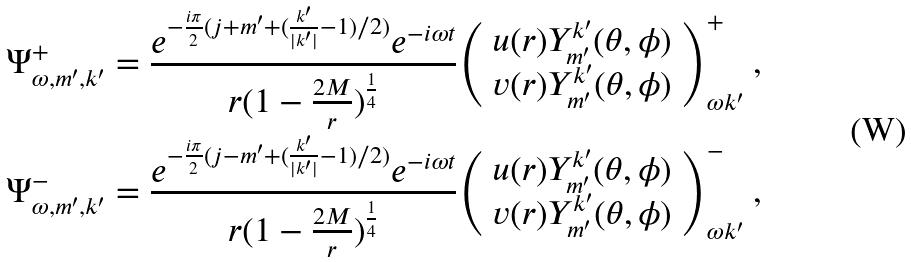Convert formula to latex. <formula><loc_0><loc_0><loc_500><loc_500>\Psi ^ { + } _ { \omega , m ^ { \prime } , k ^ { \prime } } & = \frac { e ^ { - \frac { i \pi } { 2 } ( j + m ^ { \prime } + ( \frac { k ^ { \prime } } { | k ^ { \prime } | } - 1 ) / 2 ) } e ^ { - i \omega { t } } } { r ( 1 - \frac { 2 M } { r } ) ^ { \frac { 1 } { 4 } } } { { \left ( \begin{array} { c } u ( r ) Y ^ { k ^ { \prime } } _ { m ^ { \prime } } ( \theta , \phi ) \\ v ( r ) Y ^ { k ^ { \prime } } _ { m ^ { \prime } } ( \theta , \phi ) \\ \end{array} \right ) } } ^ { + } _ { \omega { k ^ { \prime } } } \ , \\ \Psi ^ { - } _ { \omega , m ^ { \prime } , k ^ { \prime } } & = \frac { e ^ { - \frac { i \pi } { 2 } ( j - m ^ { \prime } + ( \frac { k ^ { \prime } } { | k ^ { \prime } | } - 1 ) / 2 ) } e ^ { - i \omega { t } } } { r ( 1 - \frac { 2 M } { r } ) ^ { \frac { 1 } { 4 } } } { { \left ( \begin{array} { c } u ( r ) Y ^ { k ^ { \prime } } _ { m ^ { \prime } } ( \theta , \phi ) \\ v ( r ) Y ^ { k ^ { \prime } } _ { m ^ { \prime } } ( \theta , \phi ) \\ \end{array} \right ) } } ^ { - } _ { \omega { k ^ { \prime } } } \ ,</formula> 